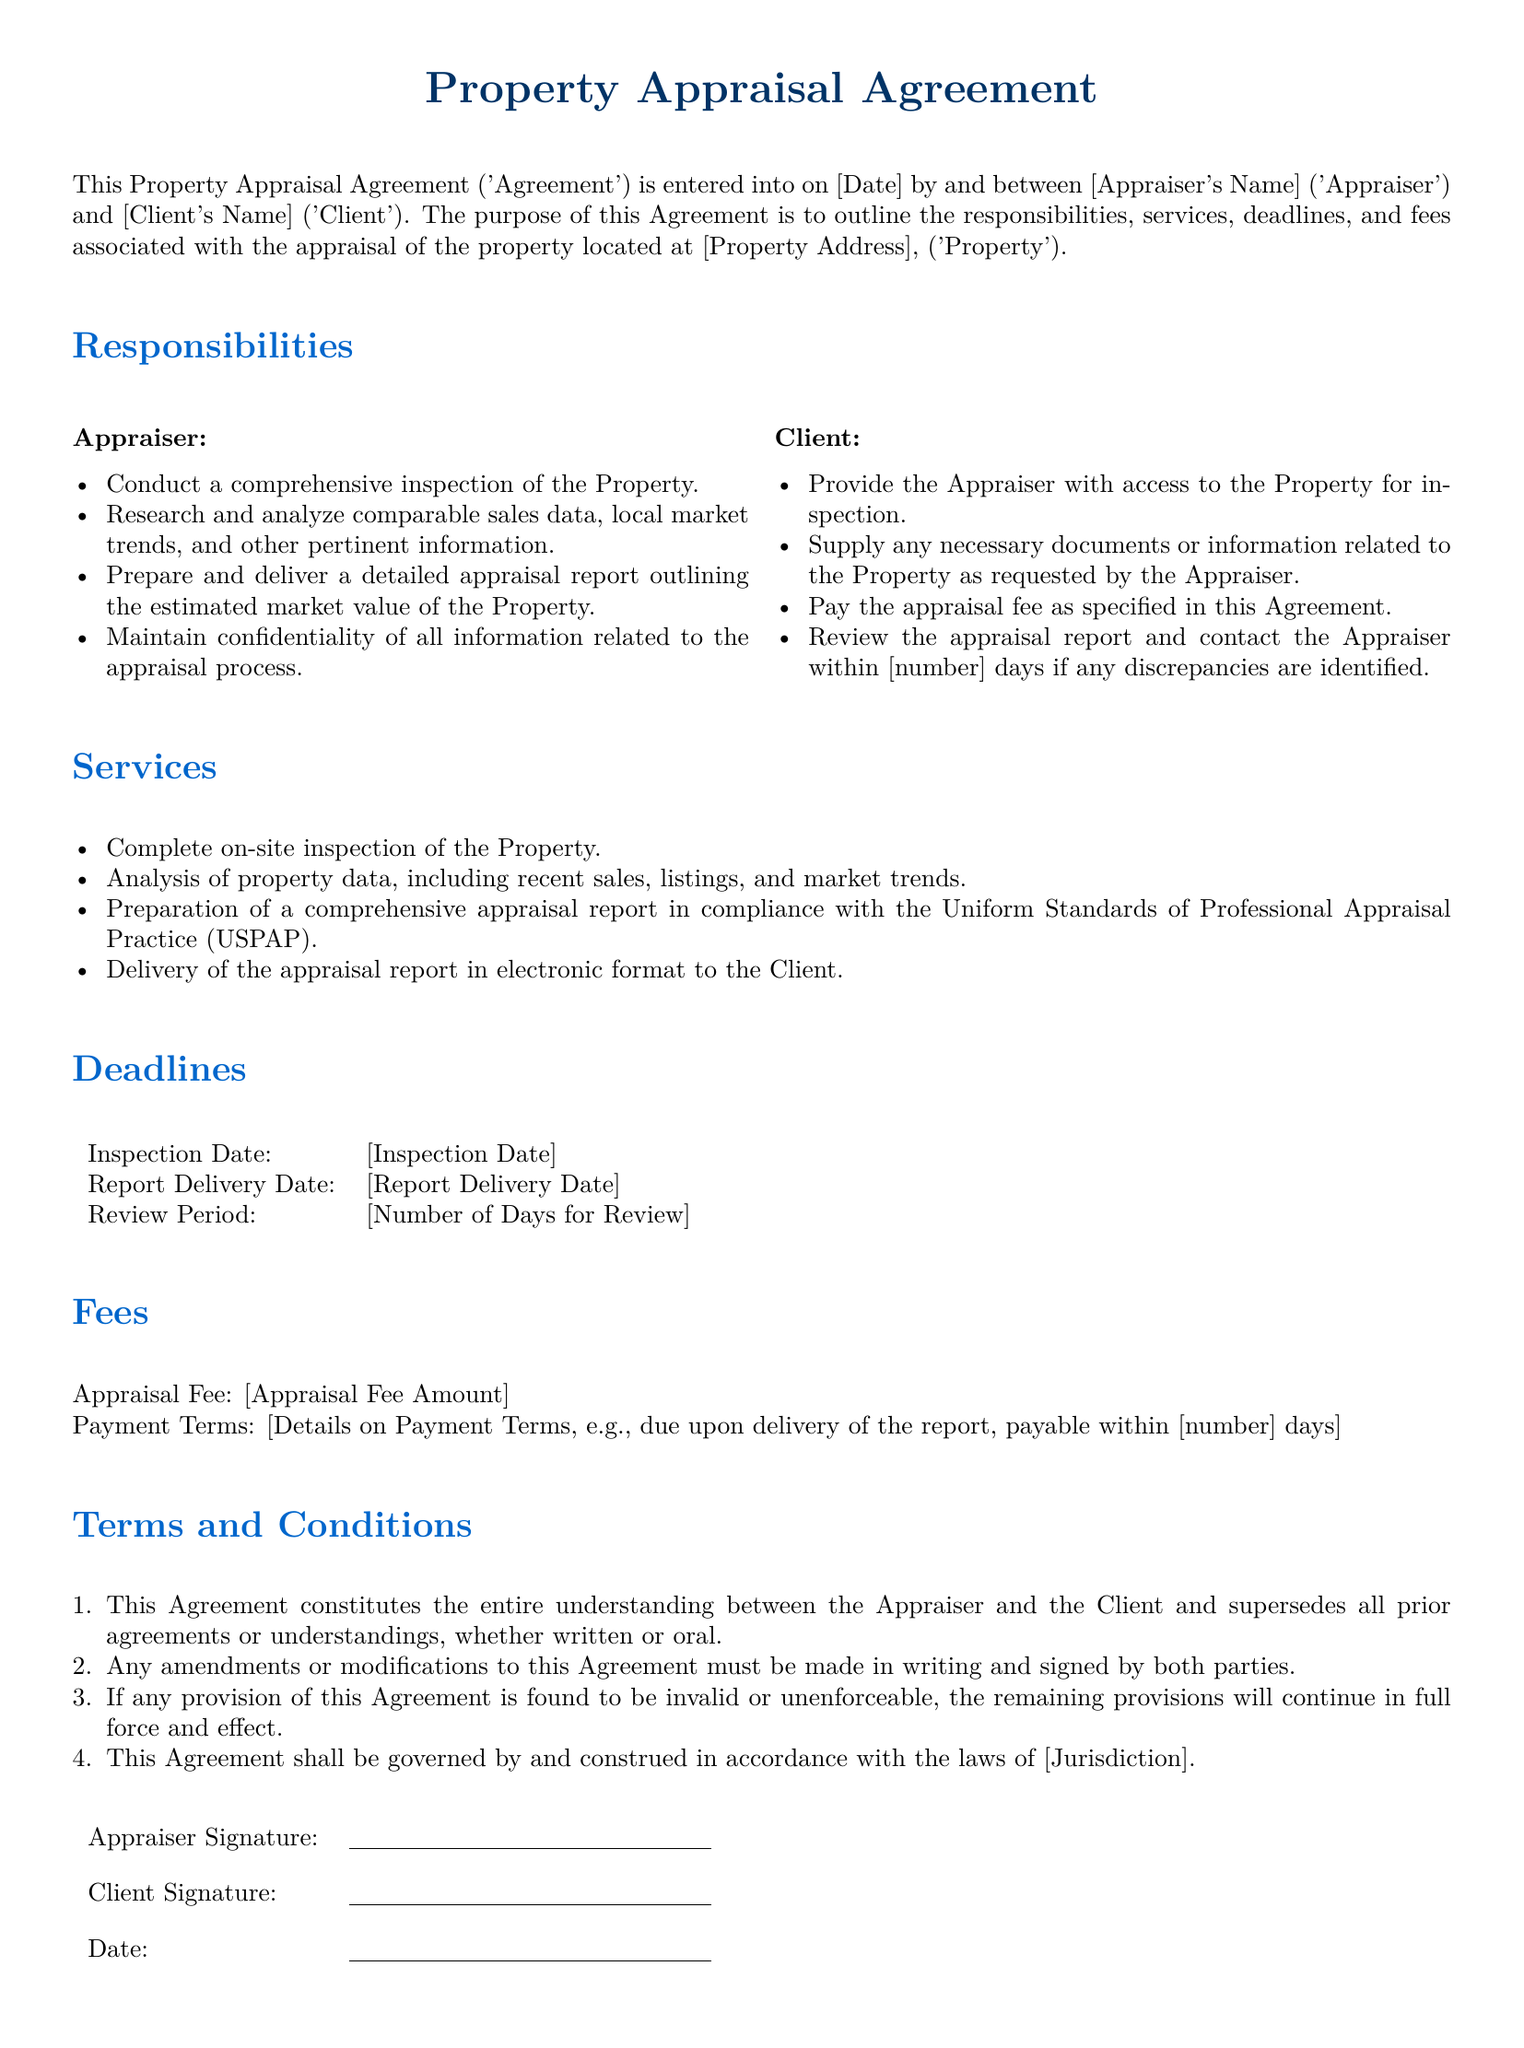what is the title of the document? The title of the document is stated at the top as "Property Appraisal Agreement."
Answer: Property Appraisal Agreement who are the parties involved in this agreement? The parties involved in the agreement are the Appraiser and the Client.
Answer: Appraiser and Client what is the Appraiser required to conduct? The Appraiser is required to conduct a comprehensive inspection of the Property.
Answer: a comprehensive inspection of the Property when is the report delivery date? The report delivery date is a variable specified in the document as [Report Delivery Date].
Answer: [Report Delivery Date] how long does the Client have to review the appraisal report? The Client must contact the Appraiser within [number] days if any discrepancies are identified.
Answer: [number] days what is the payment term for the appraisal fee? The payment terms are details specified in the document, such as due upon delivery of the report.
Answer: [Details on Payment Terms] what must be included in the appraisal report? The appraisal report must be prepared in compliance with the Uniform Standards of Professional Appraisal Practice (USPAP).
Answer: compliance with USPAP what happens if any provision of this Agreement is found invalid? If any provision is found to be invalid or unenforceable, the remaining provisions will continue in full force and effect.
Answer: remaining provisions will continue in full force and effect who signs the agreement? The agreement must be signed by both the Appraiser and the Client.
Answer: Appraiser and Client 